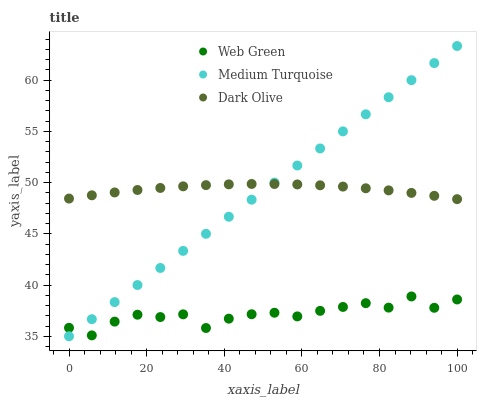Does Web Green have the minimum area under the curve?
Answer yes or no. Yes. Does Dark Olive have the maximum area under the curve?
Answer yes or no. Yes. Does Medium Turquoise have the minimum area under the curve?
Answer yes or no. No. Does Medium Turquoise have the maximum area under the curve?
Answer yes or no. No. Is Medium Turquoise the smoothest?
Answer yes or no. Yes. Is Web Green the roughest?
Answer yes or no. Yes. Is Web Green the smoothest?
Answer yes or no. No. Is Medium Turquoise the roughest?
Answer yes or no. No. Does Medium Turquoise have the lowest value?
Answer yes or no. Yes. Does Web Green have the lowest value?
Answer yes or no. No. Does Medium Turquoise have the highest value?
Answer yes or no. Yes. Does Web Green have the highest value?
Answer yes or no. No. Is Web Green less than Dark Olive?
Answer yes or no. Yes. Is Dark Olive greater than Web Green?
Answer yes or no. Yes. Does Web Green intersect Medium Turquoise?
Answer yes or no. Yes. Is Web Green less than Medium Turquoise?
Answer yes or no. No. Is Web Green greater than Medium Turquoise?
Answer yes or no. No. Does Web Green intersect Dark Olive?
Answer yes or no. No. 